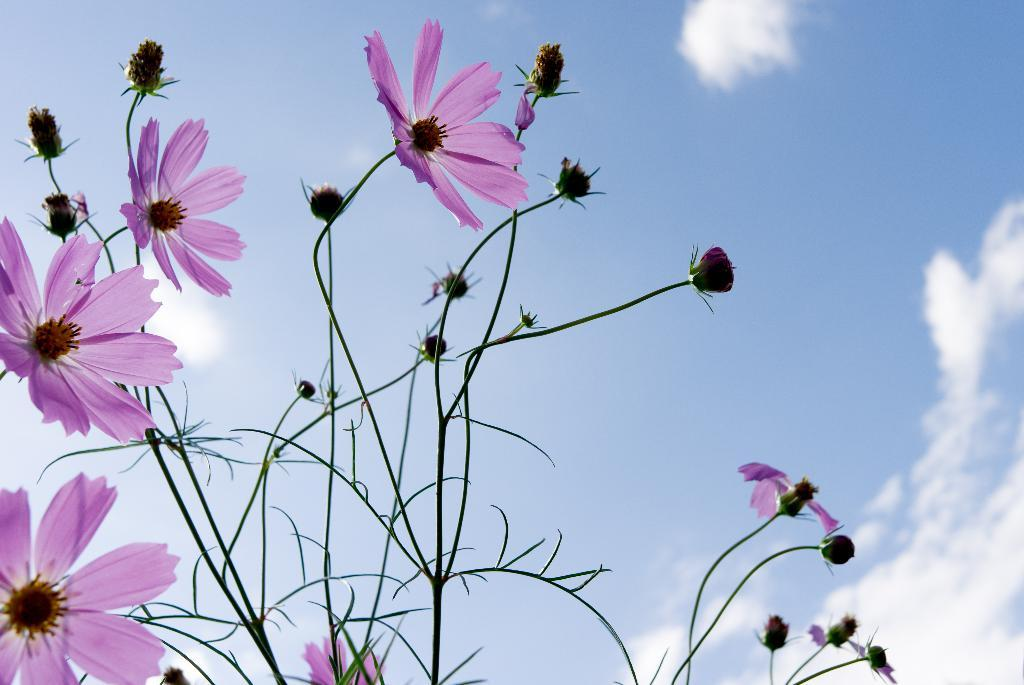What is the main subject in the middle of the image? There is a plant in the middle of the image. What additional features are associated with the plant? There are flowers associated with the plant. What can be seen in the background of the image? There are clouds visible in the sky in the background of the image. How many ears can be seen on the plant in the image? There are no ears present on the plant in the image, as plants do not have ears. 